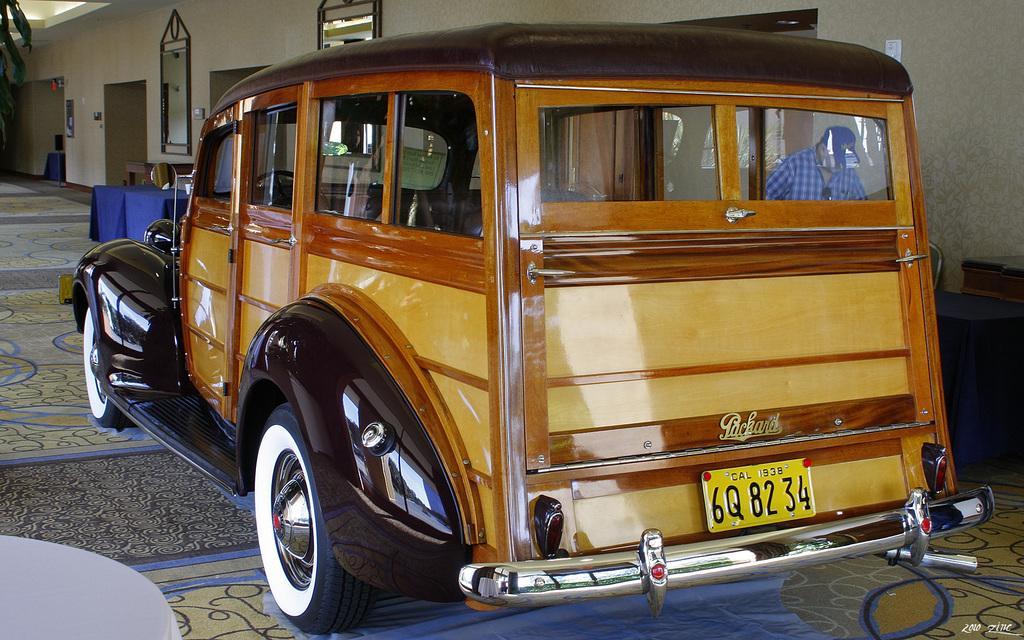In one or two sentences, can you explain what this image depicts? In this picture there is a car which is parked near to the wall. Here we can see a man who is wearing cap, shirt and goggles. He is standing near to the door. On the right we can see dustbin and table. On the left we can see blue color cloth which is covered on the table. Beside that we can see mirrors. On the bottom right corner there is a watermark. 